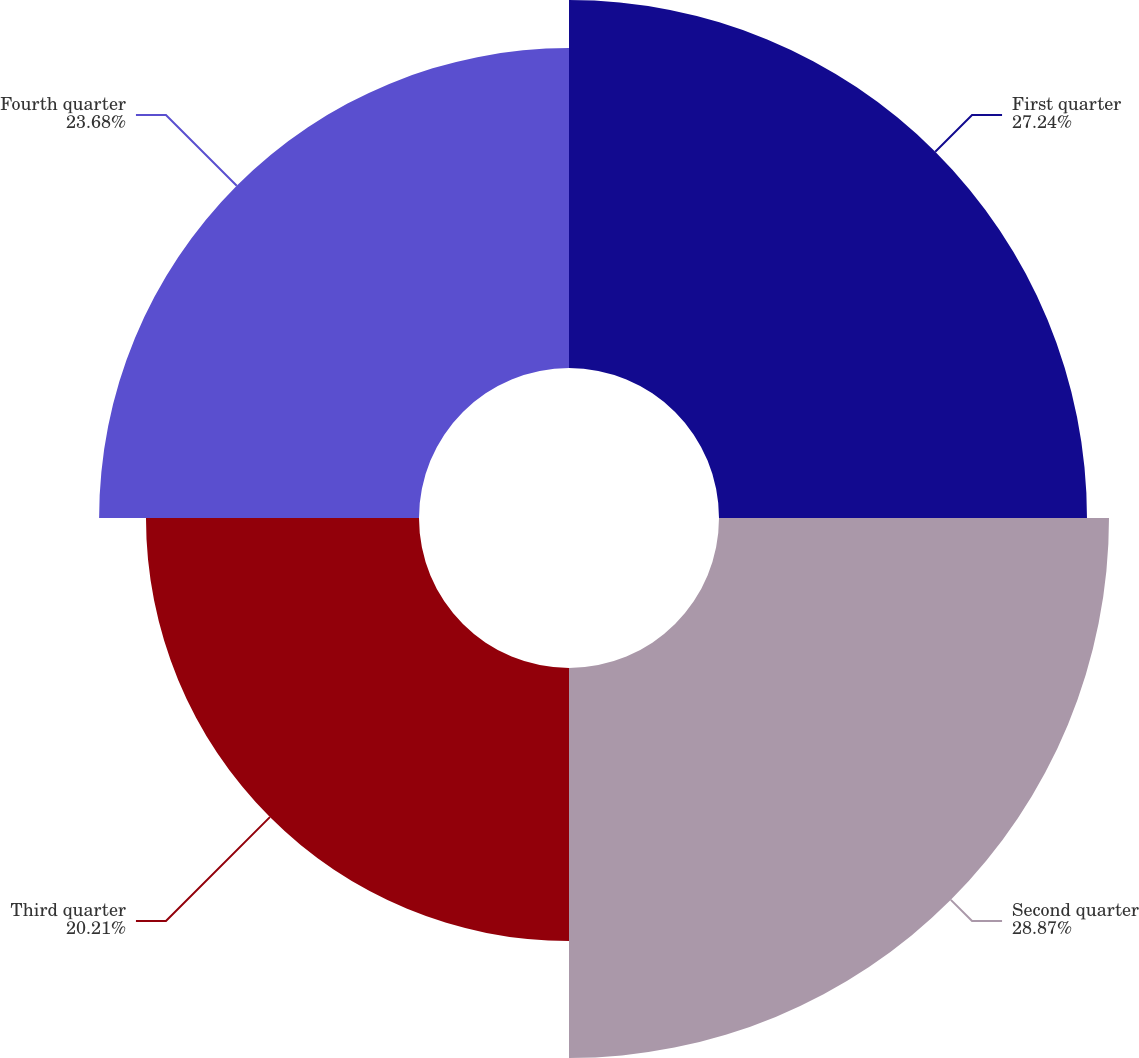<chart> <loc_0><loc_0><loc_500><loc_500><pie_chart><fcel>First quarter<fcel>Second quarter<fcel>Third quarter<fcel>Fourth quarter<nl><fcel>27.24%<fcel>28.87%<fcel>20.21%<fcel>23.68%<nl></chart> 